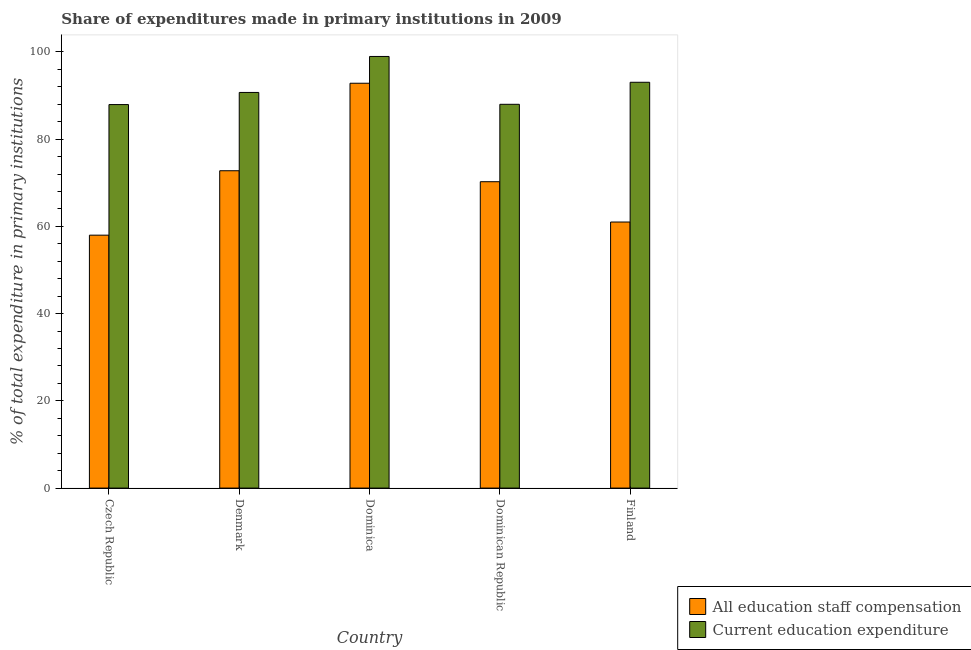How many different coloured bars are there?
Offer a very short reply. 2. What is the label of the 1st group of bars from the left?
Keep it short and to the point. Czech Republic. In how many cases, is the number of bars for a given country not equal to the number of legend labels?
Your answer should be compact. 0. What is the expenditure in education in Dominican Republic?
Make the answer very short. 88. Across all countries, what is the maximum expenditure in staff compensation?
Your answer should be compact. 92.83. Across all countries, what is the minimum expenditure in education?
Provide a succinct answer. 87.94. In which country was the expenditure in education maximum?
Give a very brief answer. Dominica. In which country was the expenditure in staff compensation minimum?
Offer a terse response. Czech Republic. What is the total expenditure in staff compensation in the graph?
Make the answer very short. 354.84. What is the difference between the expenditure in education in Dominica and that in Finland?
Ensure brevity in your answer.  5.92. What is the difference between the expenditure in staff compensation in Czech Republic and the expenditure in education in Dominican Republic?
Your response must be concise. -30.01. What is the average expenditure in staff compensation per country?
Offer a terse response. 70.97. What is the difference between the expenditure in staff compensation and expenditure in education in Czech Republic?
Ensure brevity in your answer.  -29.95. What is the ratio of the expenditure in education in Dominica to that in Dominican Republic?
Your response must be concise. 1.12. Is the expenditure in staff compensation in Denmark less than that in Dominica?
Your response must be concise. Yes. Is the difference between the expenditure in staff compensation in Dominica and Finland greater than the difference between the expenditure in education in Dominica and Finland?
Make the answer very short. Yes. What is the difference between the highest and the second highest expenditure in education?
Keep it short and to the point. 5.92. What is the difference between the highest and the lowest expenditure in education?
Give a very brief answer. 11.03. In how many countries, is the expenditure in education greater than the average expenditure in education taken over all countries?
Give a very brief answer. 2. What does the 2nd bar from the left in Denmark represents?
Provide a succinct answer. Current education expenditure. What does the 2nd bar from the right in Denmark represents?
Keep it short and to the point. All education staff compensation. How many bars are there?
Keep it short and to the point. 10. How many countries are there in the graph?
Offer a very short reply. 5. Does the graph contain any zero values?
Provide a succinct answer. No. Does the graph contain grids?
Offer a terse response. No. Where does the legend appear in the graph?
Your answer should be compact. Bottom right. What is the title of the graph?
Provide a succinct answer. Share of expenditures made in primary institutions in 2009. What is the label or title of the Y-axis?
Your answer should be very brief. % of total expenditure in primary institutions. What is the % of total expenditure in primary institutions of All education staff compensation in Czech Republic?
Give a very brief answer. 57.99. What is the % of total expenditure in primary institutions of Current education expenditure in Czech Republic?
Your response must be concise. 87.94. What is the % of total expenditure in primary institutions in All education staff compensation in Denmark?
Your answer should be compact. 72.77. What is the % of total expenditure in primary institutions of Current education expenditure in Denmark?
Offer a very short reply. 90.72. What is the % of total expenditure in primary institutions of All education staff compensation in Dominica?
Your answer should be very brief. 92.83. What is the % of total expenditure in primary institutions of Current education expenditure in Dominica?
Your response must be concise. 98.97. What is the % of total expenditure in primary institutions in All education staff compensation in Dominican Republic?
Your answer should be compact. 70.25. What is the % of total expenditure in primary institutions in Current education expenditure in Dominican Republic?
Provide a short and direct response. 88. What is the % of total expenditure in primary institutions of All education staff compensation in Finland?
Ensure brevity in your answer.  61.01. What is the % of total expenditure in primary institutions in Current education expenditure in Finland?
Keep it short and to the point. 93.05. Across all countries, what is the maximum % of total expenditure in primary institutions of All education staff compensation?
Provide a succinct answer. 92.83. Across all countries, what is the maximum % of total expenditure in primary institutions in Current education expenditure?
Your answer should be very brief. 98.97. Across all countries, what is the minimum % of total expenditure in primary institutions in All education staff compensation?
Your answer should be very brief. 57.99. Across all countries, what is the minimum % of total expenditure in primary institutions of Current education expenditure?
Your answer should be very brief. 87.94. What is the total % of total expenditure in primary institutions in All education staff compensation in the graph?
Provide a succinct answer. 354.84. What is the total % of total expenditure in primary institutions in Current education expenditure in the graph?
Make the answer very short. 458.68. What is the difference between the % of total expenditure in primary institutions in All education staff compensation in Czech Republic and that in Denmark?
Give a very brief answer. -14.77. What is the difference between the % of total expenditure in primary institutions of Current education expenditure in Czech Republic and that in Denmark?
Make the answer very short. -2.78. What is the difference between the % of total expenditure in primary institutions in All education staff compensation in Czech Republic and that in Dominica?
Keep it short and to the point. -34.84. What is the difference between the % of total expenditure in primary institutions in Current education expenditure in Czech Republic and that in Dominica?
Keep it short and to the point. -11.03. What is the difference between the % of total expenditure in primary institutions in All education staff compensation in Czech Republic and that in Dominican Republic?
Provide a succinct answer. -12.26. What is the difference between the % of total expenditure in primary institutions in Current education expenditure in Czech Republic and that in Dominican Republic?
Give a very brief answer. -0.06. What is the difference between the % of total expenditure in primary institutions of All education staff compensation in Czech Republic and that in Finland?
Offer a terse response. -3.01. What is the difference between the % of total expenditure in primary institutions in Current education expenditure in Czech Republic and that in Finland?
Provide a succinct answer. -5.11. What is the difference between the % of total expenditure in primary institutions in All education staff compensation in Denmark and that in Dominica?
Provide a succinct answer. -20.06. What is the difference between the % of total expenditure in primary institutions in Current education expenditure in Denmark and that in Dominica?
Provide a succinct answer. -8.25. What is the difference between the % of total expenditure in primary institutions of All education staff compensation in Denmark and that in Dominican Republic?
Make the answer very short. 2.52. What is the difference between the % of total expenditure in primary institutions of Current education expenditure in Denmark and that in Dominican Republic?
Provide a short and direct response. 2.72. What is the difference between the % of total expenditure in primary institutions of All education staff compensation in Denmark and that in Finland?
Offer a very short reply. 11.76. What is the difference between the % of total expenditure in primary institutions of Current education expenditure in Denmark and that in Finland?
Offer a very short reply. -2.33. What is the difference between the % of total expenditure in primary institutions of All education staff compensation in Dominica and that in Dominican Republic?
Ensure brevity in your answer.  22.58. What is the difference between the % of total expenditure in primary institutions in Current education expenditure in Dominica and that in Dominican Republic?
Your answer should be very brief. 10.97. What is the difference between the % of total expenditure in primary institutions in All education staff compensation in Dominica and that in Finland?
Give a very brief answer. 31.82. What is the difference between the % of total expenditure in primary institutions in Current education expenditure in Dominica and that in Finland?
Your answer should be very brief. 5.92. What is the difference between the % of total expenditure in primary institutions of All education staff compensation in Dominican Republic and that in Finland?
Your response must be concise. 9.24. What is the difference between the % of total expenditure in primary institutions in Current education expenditure in Dominican Republic and that in Finland?
Keep it short and to the point. -5.05. What is the difference between the % of total expenditure in primary institutions in All education staff compensation in Czech Republic and the % of total expenditure in primary institutions in Current education expenditure in Denmark?
Give a very brief answer. -32.73. What is the difference between the % of total expenditure in primary institutions of All education staff compensation in Czech Republic and the % of total expenditure in primary institutions of Current education expenditure in Dominica?
Offer a very short reply. -40.98. What is the difference between the % of total expenditure in primary institutions in All education staff compensation in Czech Republic and the % of total expenditure in primary institutions in Current education expenditure in Dominican Republic?
Ensure brevity in your answer.  -30.01. What is the difference between the % of total expenditure in primary institutions in All education staff compensation in Czech Republic and the % of total expenditure in primary institutions in Current education expenditure in Finland?
Keep it short and to the point. -35.06. What is the difference between the % of total expenditure in primary institutions in All education staff compensation in Denmark and the % of total expenditure in primary institutions in Current education expenditure in Dominica?
Your answer should be compact. -26.2. What is the difference between the % of total expenditure in primary institutions of All education staff compensation in Denmark and the % of total expenditure in primary institutions of Current education expenditure in Dominican Republic?
Make the answer very short. -15.23. What is the difference between the % of total expenditure in primary institutions in All education staff compensation in Denmark and the % of total expenditure in primary institutions in Current education expenditure in Finland?
Offer a terse response. -20.28. What is the difference between the % of total expenditure in primary institutions in All education staff compensation in Dominica and the % of total expenditure in primary institutions in Current education expenditure in Dominican Republic?
Provide a succinct answer. 4.83. What is the difference between the % of total expenditure in primary institutions in All education staff compensation in Dominica and the % of total expenditure in primary institutions in Current education expenditure in Finland?
Provide a short and direct response. -0.22. What is the difference between the % of total expenditure in primary institutions of All education staff compensation in Dominican Republic and the % of total expenditure in primary institutions of Current education expenditure in Finland?
Your answer should be very brief. -22.8. What is the average % of total expenditure in primary institutions in All education staff compensation per country?
Provide a short and direct response. 70.97. What is the average % of total expenditure in primary institutions of Current education expenditure per country?
Provide a succinct answer. 91.74. What is the difference between the % of total expenditure in primary institutions of All education staff compensation and % of total expenditure in primary institutions of Current education expenditure in Czech Republic?
Provide a succinct answer. -29.95. What is the difference between the % of total expenditure in primary institutions of All education staff compensation and % of total expenditure in primary institutions of Current education expenditure in Denmark?
Provide a short and direct response. -17.95. What is the difference between the % of total expenditure in primary institutions of All education staff compensation and % of total expenditure in primary institutions of Current education expenditure in Dominica?
Your answer should be compact. -6.14. What is the difference between the % of total expenditure in primary institutions of All education staff compensation and % of total expenditure in primary institutions of Current education expenditure in Dominican Republic?
Your answer should be very brief. -17.75. What is the difference between the % of total expenditure in primary institutions of All education staff compensation and % of total expenditure in primary institutions of Current education expenditure in Finland?
Provide a short and direct response. -32.04. What is the ratio of the % of total expenditure in primary institutions in All education staff compensation in Czech Republic to that in Denmark?
Your answer should be very brief. 0.8. What is the ratio of the % of total expenditure in primary institutions of Current education expenditure in Czech Republic to that in Denmark?
Ensure brevity in your answer.  0.97. What is the ratio of the % of total expenditure in primary institutions of All education staff compensation in Czech Republic to that in Dominica?
Offer a terse response. 0.62. What is the ratio of the % of total expenditure in primary institutions in Current education expenditure in Czech Republic to that in Dominica?
Your response must be concise. 0.89. What is the ratio of the % of total expenditure in primary institutions in All education staff compensation in Czech Republic to that in Dominican Republic?
Your answer should be compact. 0.83. What is the ratio of the % of total expenditure in primary institutions in All education staff compensation in Czech Republic to that in Finland?
Give a very brief answer. 0.95. What is the ratio of the % of total expenditure in primary institutions in Current education expenditure in Czech Republic to that in Finland?
Offer a very short reply. 0.95. What is the ratio of the % of total expenditure in primary institutions in All education staff compensation in Denmark to that in Dominica?
Give a very brief answer. 0.78. What is the ratio of the % of total expenditure in primary institutions of Current education expenditure in Denmark to that in Dominica?
Keep it short and to the point. 0.92. What is the ratio of the % of total expenditure in primary institutions of All education staff compensation in Denmark to that in Dominican Republic?
Make the answer very short. 1.04. What is the ratio of the % of total expenditure in primary institutions of Current education expenditure in Denmark to that in Dominican Republic?
Make the answer very short. 1.03. What is the ratio of the % of total expenditure in primary institutions of All education staff compensation in Denmark to that in Finland?
Make the answer very short. 1.19. What is the ratio of the % of total expenditure in primary institutions in Current education expenditure in Denmark to that in Finland?
Offer a very short reply. 0.97. What is the ratio of the % of total expenditure in primary institutions in All education staff compensation in Dominica to that in Dominican Republic?
Keep it short and to the point. 1.32. What is the ratio of the % of total expenditure in primary institutions in Current education expenditure in Dominica to that in Dominican Republic?
Offer a terse response. 1.12. What is the ratio of the % of total expenditure in primary institutions of All education staff compensation in Dominica to that in Finland?
Provide a succinct answer. 1.52. What is the ratio of the % of total expenditure in primary institutions of Current education expenditure in Dominica to that in Finland?
Provide a short and direct response. 1.06. What is the ratio of the % of total expenditure in primary institutions in All education staff compensation in Dominican Republic to that in Finland?
Give a very brief answer. 1.15. What is the ratio of the % of total expenditure in primary institutions in Current education expenditure in Dominican Republic to that in Finland?
Offer a terse response. 0.95. What is the difference between the highest and the second highest % of total expenditure in primary institutions of All education staff compensation?
Your response must be concise. 20.06. What is the difference between the highest and the second highest % of total expenditure in primary institutions in Current education expenditure?
Provide a short and direct response. 5.92. What is the difference between the highest and the lowest % of total expenditure in primary institutions in All education staff compensation?
Offer a terse response. 34.84. What is the difference between the highest and the lowest % of total expenditure in primary institutions of Current education expenditure?
Offer a terse response. 11.03. 